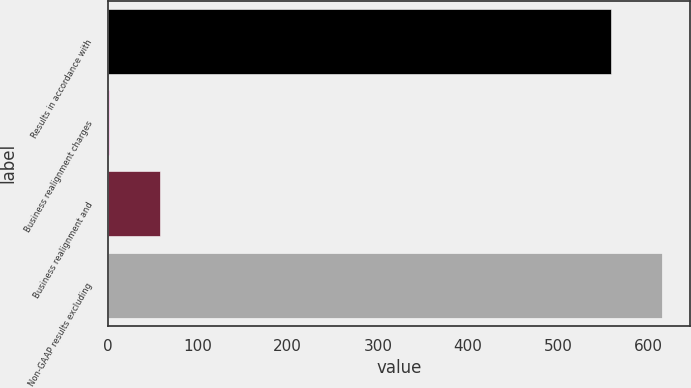Convert chart to OTSL. <chart><loc_0><loc_0><loc_500><loc_500><bar_chart><fcel>Results in accordance with<fcel>Business realignment charges<fcel>Business realignment and<fcel>Non-GAAP results excluding<nl><fcel>559.1<fcel>2<fcel>58.46<fcel>615.56<nl></chart> 